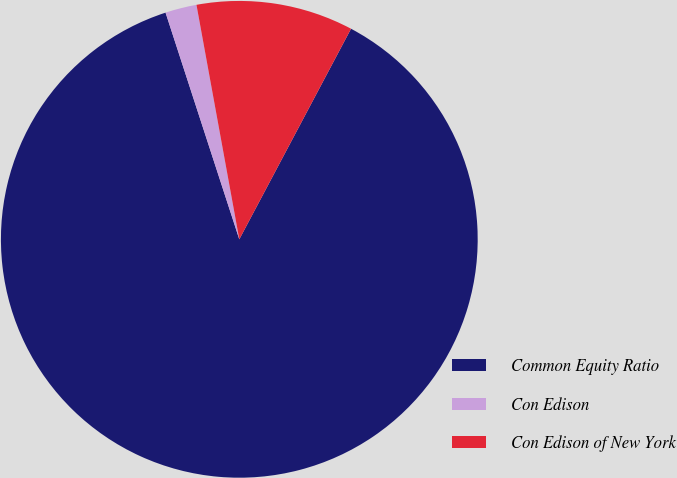Convert chart. <chart><loc_0><loc_0><loc_500><loc_500><pie_chart><fcel>Common Equity Ratio<fcel>Con Edison<fcel>Con Edison of New York<nl><fcel>87.23%<fcel>2.13%<fcel>10.64%<nl></chart> 